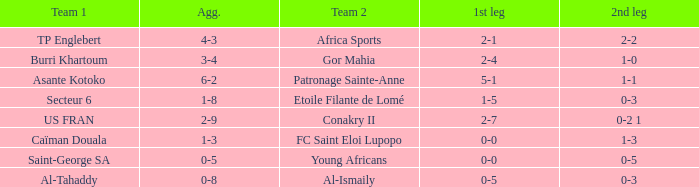Which teams had an aggregate score of 3-4? Burri Khartoum. 